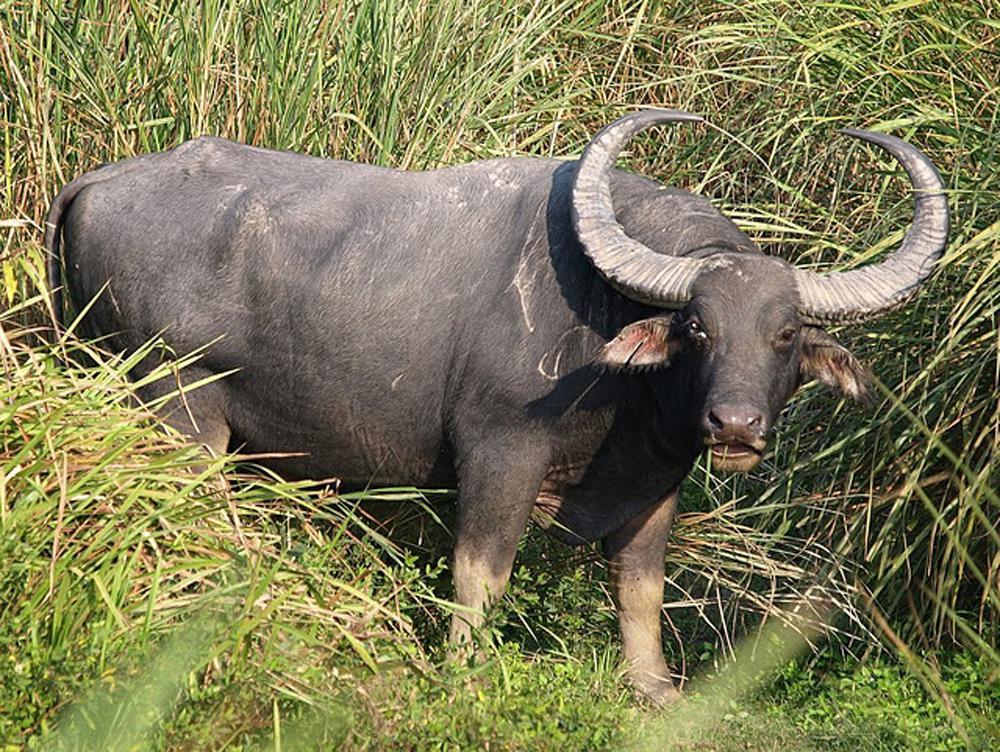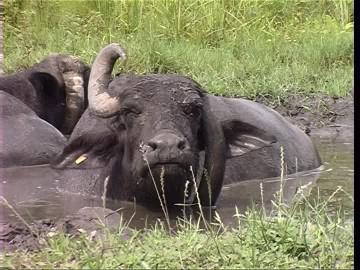The first image is the image on the left, the second image is the image on the right. Assess this claim about the two images: "An image shows an ox-type animal in the mud.". Correct or not? Answer yes or no. Yes. 